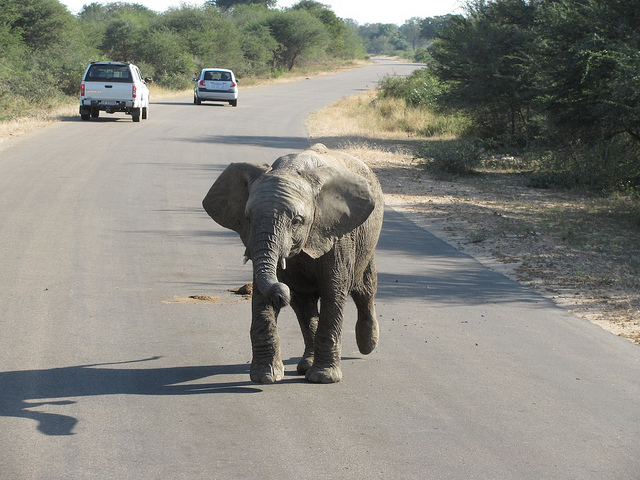What time of day does it appear to be in the image? The shadows are long and the lighting is soft, suggesting it is either early in the morning or late in the afternoon. 